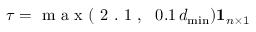Convert formula to latex. <formula><loc_0><loc_0><loc_500><loc_500>\tau = m a x ( 2 . 1 , \, 0 . 1 \, d _ { \min } ) 1 _ { n \times 1 } \,</formula> 